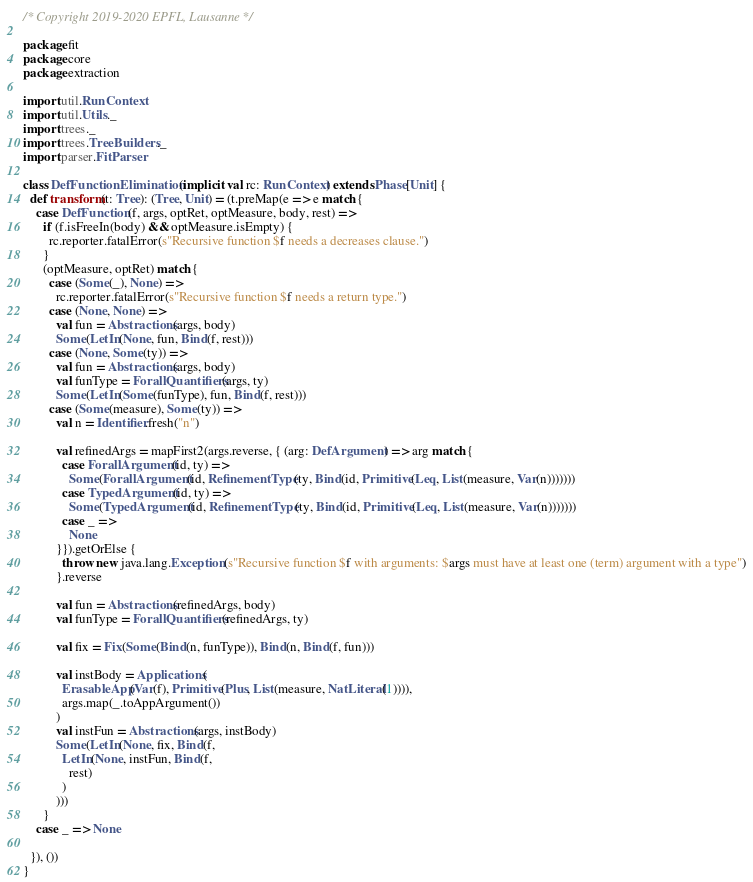<code> <loc_0><loc_0><loc_500><loc_500><_Scala_>/* Copyright 2019-2020 EPFL, Lausanne */

package fit
package core
package extraction

import util.RunContext
import util.Utils._
import trees._
import trees.TreeBuilders._
import parser.FitParser

class DefFunctionElimination(implicit val rc: RunContext) extends Phase[Unit] {
  def transform(t: Tree): (Tree, Unit) = (t.preMap(e => e match {
    case DefFunction(f, args, optRet, optMeasure, body, rest) =>
      if (f.isFreeIn(body) && optMeasure.isEmpty) {
        rc.reporter.fatalError(s"Recursive function $f needs a decreases clause.")
      }
      (optMeasure, optRet) match {
        case (Some(_), None) =>
          rc.reporter.fatalError(s"Recursive function $f needs a return type.")
        case (None, None) =>
          val fun = Abstractions(args, body)
          Some(LetIn(None, fun, Bind(f, rest)))
        case (None, Some(ty)) =>
          val fun = Abstractions(args, body)
          val funType = ForallQuantifiers(args, ty)
          Some(LetIn(Some(funType), fun, Bind(f, rest)))
        case (Some(measure), Some(ty)) =>
          val n = Identifier.fresh("n")

          val refinedArgs = mapFirst2(args.reverse, { (arg: DefArgument) => arg match {
            case ForallArgument(id, ty) =>
              Some(ForallArgument(id, RefinementType(ty, Bind(id, Primitive(Leq, List(measure, Var(n)))))))
            case TypedArgument(id, ty) =>
              Some(TypedArgument(id, RefinementType(ty, Bind(id, Primitive(Leq, List(measure, Var(n)))))))
            case _ =>
              None
          }}).getOrElse {
            throw new java.lang.Exception(s"Recursive function $f with arguments: $args must have at least one (term) argument with a type")
          }.reverse

          val fun = Abstractions(refinedArgs, body)
          val funType = ForallQuantifiers(refinedArgs, ty)

          val fix = Fix(Some(Bind(n, funType)), Bind(n, Bind(f, fun)))

          val instBody = Applications(
            ErasableApp(Var(f), Primitive(Plus, List(measure, NatLiteral(1)))),
            args.map(_.toAppArgument())
          )
          val instFun = Abstractions(args, instBody)
          Some(LetIn(None, fix, Bind(f,
            LetIn(None, instFun, Bind(f,
              rest)
            )
          )))
      }
    case _ => None

  }), ())
}
</code> 